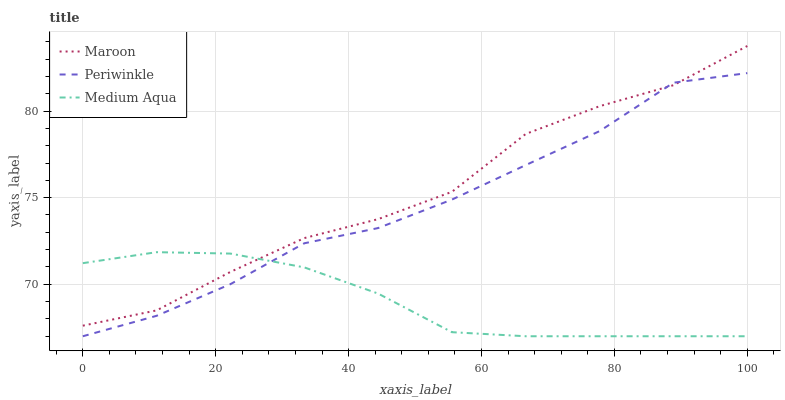Does Medium Aqua have the minimum area under the curve?
Answer yes or no. Yes. Does Maroon have the maximum area under the curve?
Answer yes or no. Yes. Does Periwinkle have the minimum area under the curve?
Answer yes or no. No. Does Periwinkle have the maximum area under the curve?
Answer yes or no. No. Is Medium Aqua the smoothest?
Answer yes or no. Yes. Is Maroon the roughest?
Answer yes or no. Yes. Is Periwinkle the smoothest?
Answer yes or no. No. Is Periwinkle the roughest?
Answer yes or no. No. Does Medium Aqua have the lowest value?
Answer yes or no. Yes. Does Maroon have the lowest value?
Answer yes or no. No. Does Maroon have the highest value?
Answer yes or no. Yes. Does Periwinkle have the highest value?
Answer yes or no. No. Does Maroon intersect Medium Aqua?
Answer yes or no. Yes. Is Maroon less than Medium Aqua?
Answer yes or no. No. Is Maroon greater than Medium Aqua?
Answer yes or no. No. 